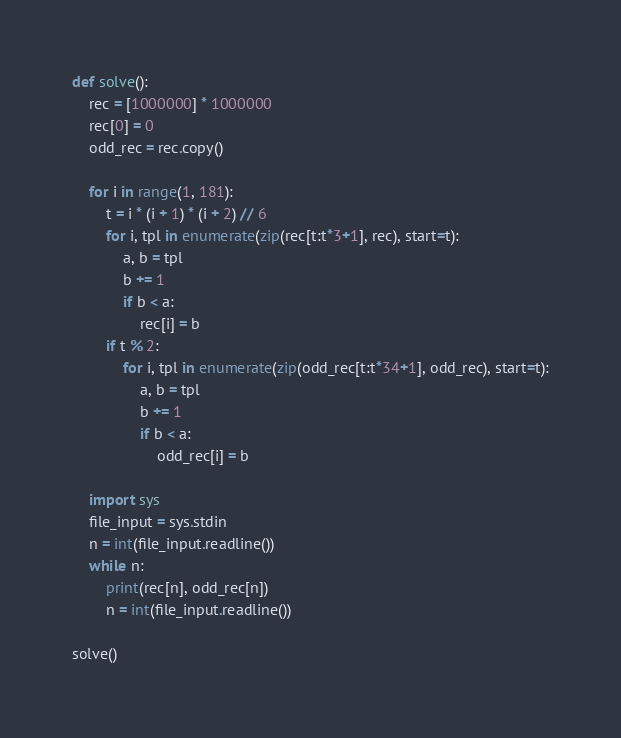<code> <loc_0><loc_0><loc_500><loc_500><_Python_>def solve():
    rec = [1000000] * 1000000
    rec[0] = 0
    odd_rec = rec.copy()
    
    for i in range(1, 181):
        t = i * (i + 1) * (i + 2) // 6
        for i, tpl in enumerate(zip(rec[t:t*3+1], rec), start=t):
            a, b = tpl
            b += 1
            if b < a:
                rec[i] = b
        if t % 2:
            for i, tpl in enumerate(zip(odd_rec[t:t*34+1], odd_rec), start=t):
                a, b = tpl
                b += 1
                if b < a:
                    odd_rec[i] = b
    
    import sys
    file_input = sys.stdin
    n = int(file_input.readline())
    while n:
        print(rec[n], odd_rec[n])
        n = int(file_input.readline())

solve()
</code> 